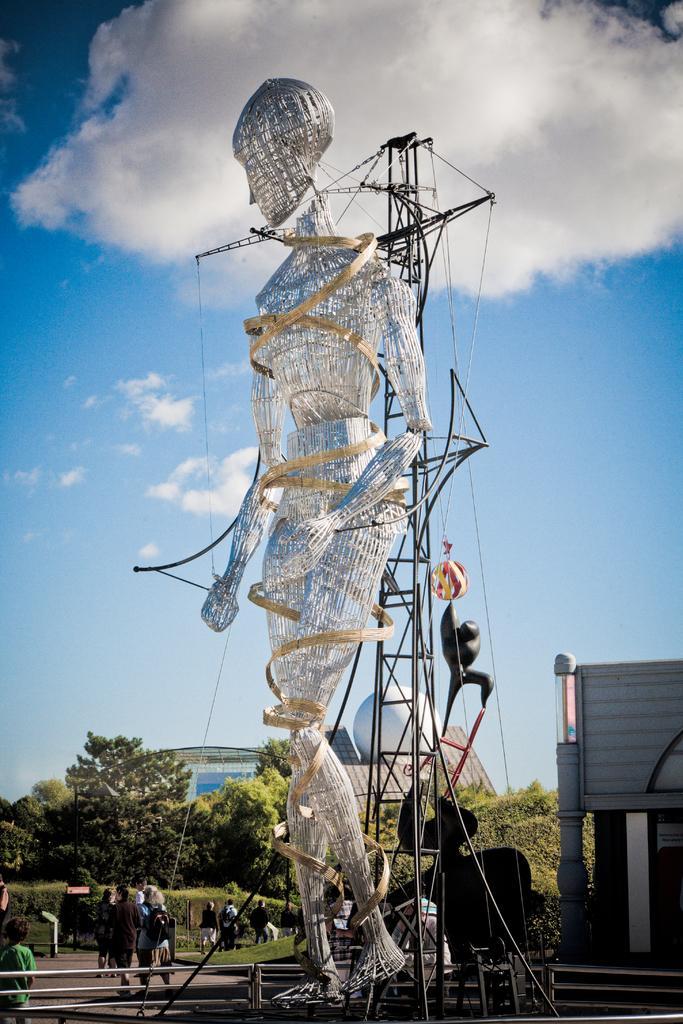In one or two sentences, can you explain what this image depicts? In this image I can see a huge statue of a person which is made up of metal rods. I can see a crane behind it. I can see the railing, few persons standing, some grass, few trees, few buildings and in the background I can see the sky. 